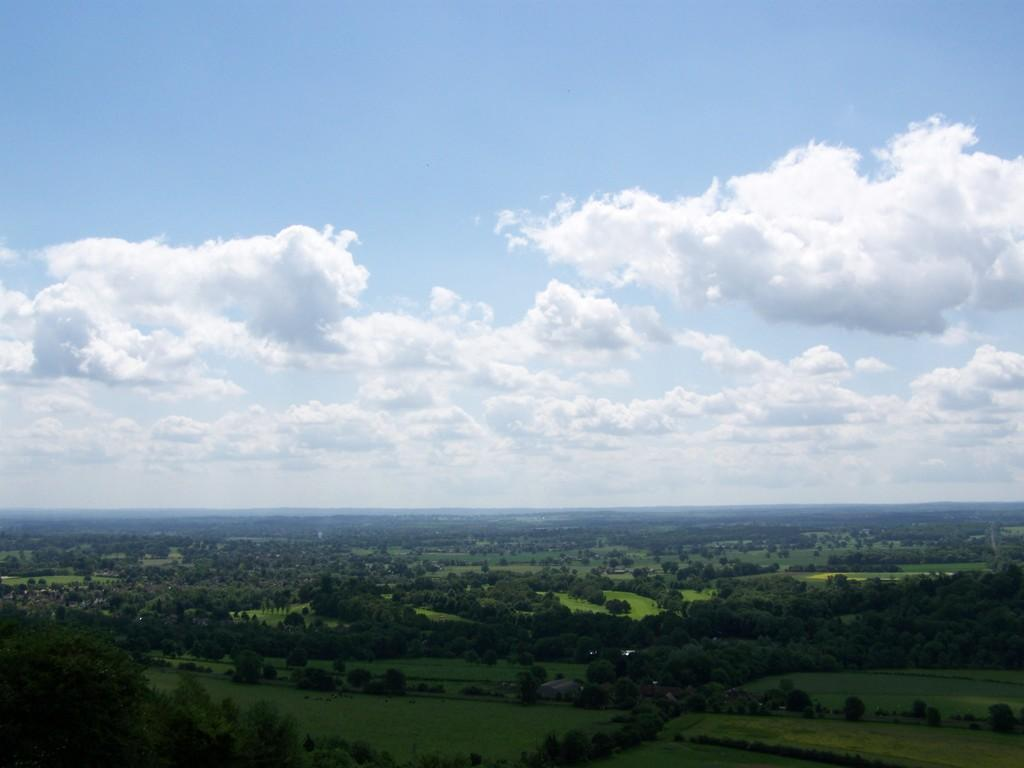What type of view is shown in the image? The image is an aerial view. What is covering the ground in the image? The ground is covered with grass. What other types of vegetation can be seen on the ground? Plants and trees are visible on the ground. What is visible in the sky in the image? Clouds are visible in the sky. Where is the sofa located in the image? There is no sofa present in the image. Can you describe the bee's activity in the image? There are no bees present in the image. 